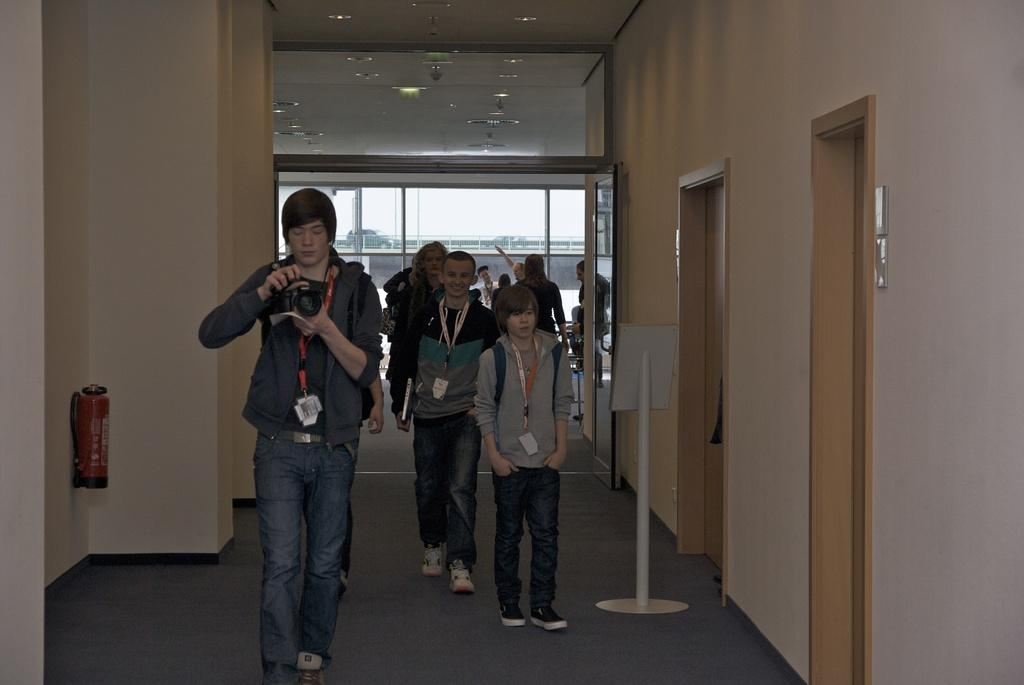How many people are in the group that is visible in the image? There is a group of people standing in the image, but the exact number cannot be determined from the provided facts. What is the person holding in the image? The person is holding a camera in the image. What type of equipment is present in the image? There is an oxygen cylinder in the image. What architectural feature can be seen in the image? There are doors in the image. What is the board attached to in the image? There is a board to a stand in the image. What is the vehicle's location in the image? There is a vehicle on a bridge in the image. What type of illumination is present in the image? There are lights in the image. What is the purpose of the sail in the image? There is no sail present in the image. What type of ball is being used by the group in the image? There is no ball present in the image. 